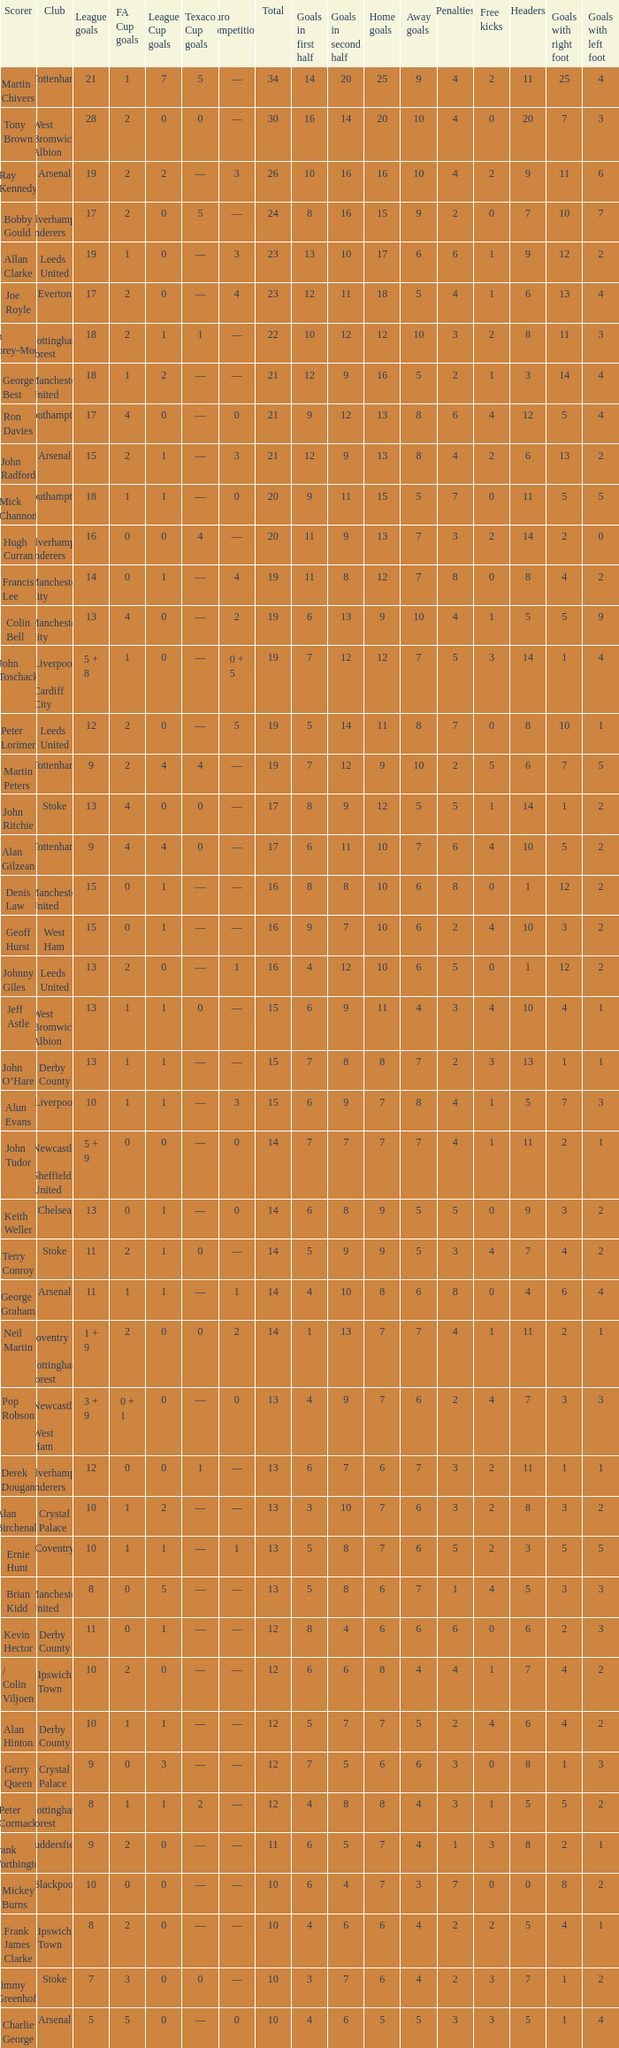What is FA Cup Goals, when Euro Competitions is 1, and when League Goals is 11? 1.0. 